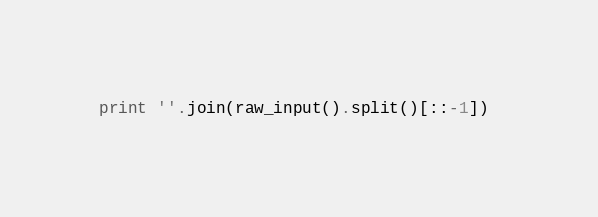Convert code to text. <code><loc_0><loc_0><loc_500><loc_500><_Python_>print ''.join(raw_input().split()[::-1]) 
</code> 